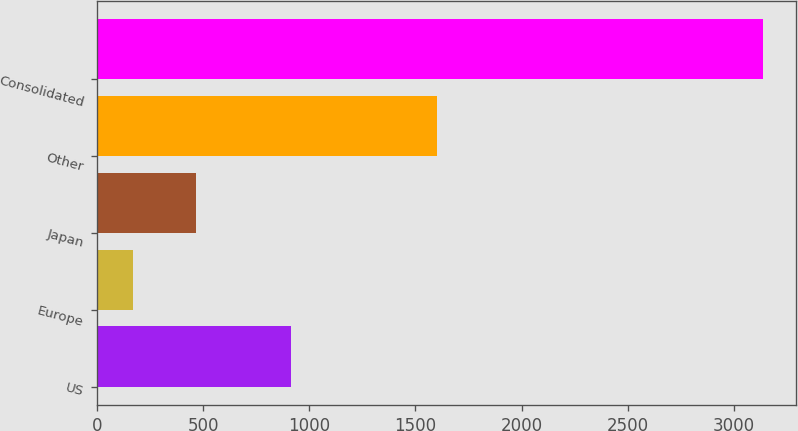Convert chart to OTSL. <chart><loc_0><loc_0><loc_500><loc_500><bar_chart><fcel>US<fcel>Europe<fcel>Japan<fcel>Other<fcel>Consolidated<nl><fcel>912<fcel>171<fcel>467.4<fcel>1603<fcel>3135<nl></chart> 